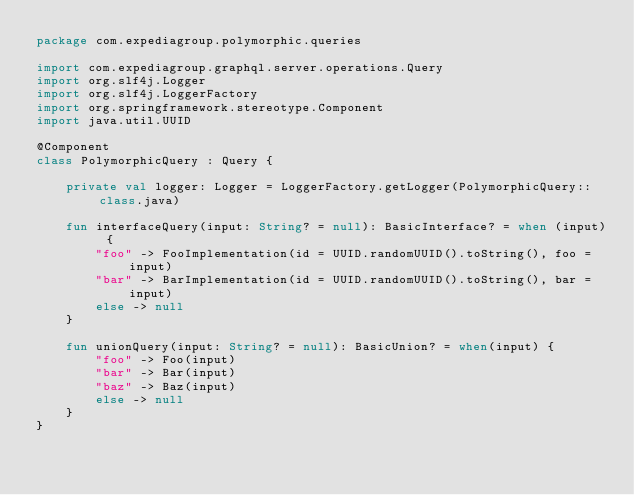<code> <loc_0><loc_0><loc_500><loc_500><_Kotlin_>package com.expediagroup.polymorphic.queries

import com.expediagroup.graphql.server.operations.Query
import org.slf4j.Logger
import org.slf4j.LoggerFactory
import org.springframework.stereotype.Component
import java.util.UUID

@Component
class PolymorphicQuery : Query {

    private val logger: Logger = LoggerFactory.getLogger(PolymorphicQuery::class.java)

    fun interfaceQuery(input: String? = null): BasicInterface? = when (input) {
        "foo" -> FooImplementation(id = UUID.randomUUID().toString(), foo = input)
        "bar" -> BarImplementation(id = UUID.randomUUID().toString(), bar = input)
        else -> null
    }

    fun unionQuery(input: String? = null): BasicUnion? = when(input) {
        "foo" -> Foo(input)
        "bar" -> Bar(input)
        "baz" -> Baz(input)
        else -> null
    }
}
</code> 